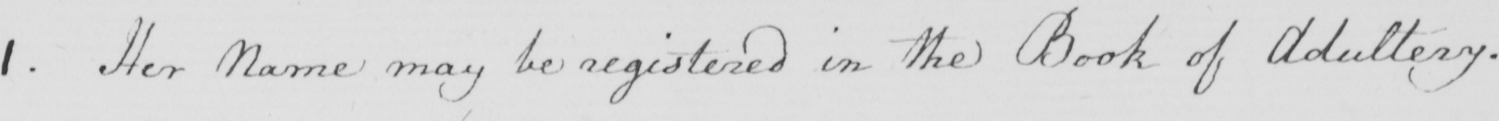What text is written in this handwritten line? 1 . Her Name may be registered in the Book of Adultery . 